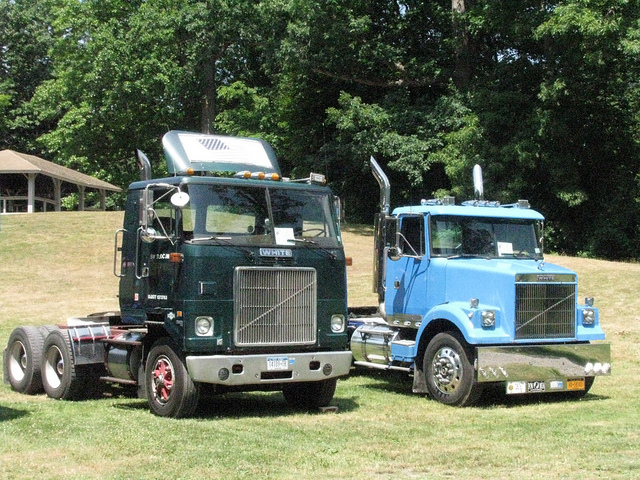Identify the text contained in this image. WHITE 